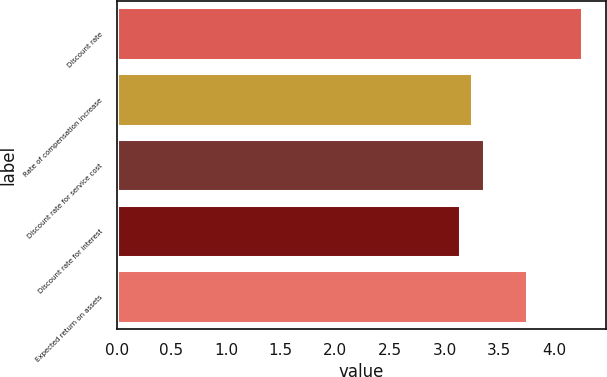Convert chart. <chart><loc_0><loc_0><loc_500><loc_500><bar_chart><fcel>Discount rate<fcel>Rate of compensation increase<fcel>Discount rate for service cost<fcel>Discount rate for interest<fcel>Expected return on assets<nl><fcel>4.26<fcel>3.25<fcel>3.36<fcel>3.14<fcel>3.75<nl></chart> 